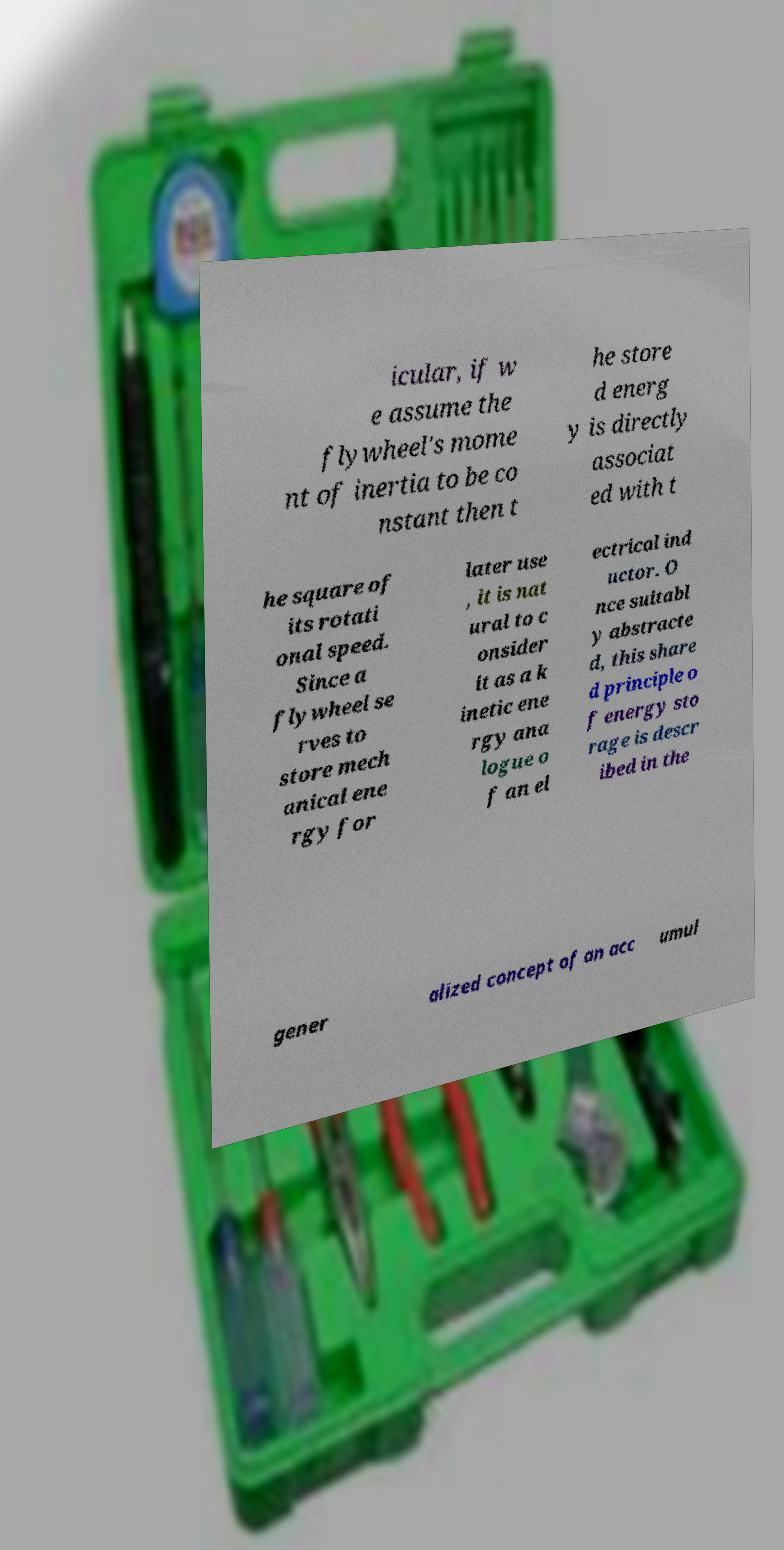Please identify and transcribe the text found in this image. icular, if w e assume the flywheel's mome nt of inertia to be co nstant then t he store d energ y is directly associat ed with t he square of its rotati onal speed. Since a flywheel se rves to store mech anical ene rgy for later use , it is nat ural to c onsider it as a k inetic ene rgy ana logue o f an el ectrical ind uctor. O nce suitabl y abstracte d, this share d principle o f energy sto rage is descr ibed in the gener alized concept of an acc umul 